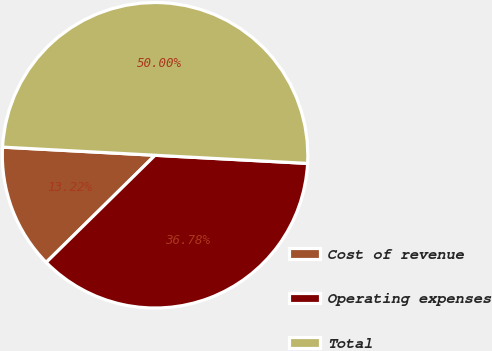<chart> <loc_0><loc_0><loc_500><loc_500><pie_chart><fcel>Cost of revenue<fcel>Operating expenses<fcel>Total<nl><fcel>13.22%<fcel>36.78%<fcel>50.0%<nl></chart> 